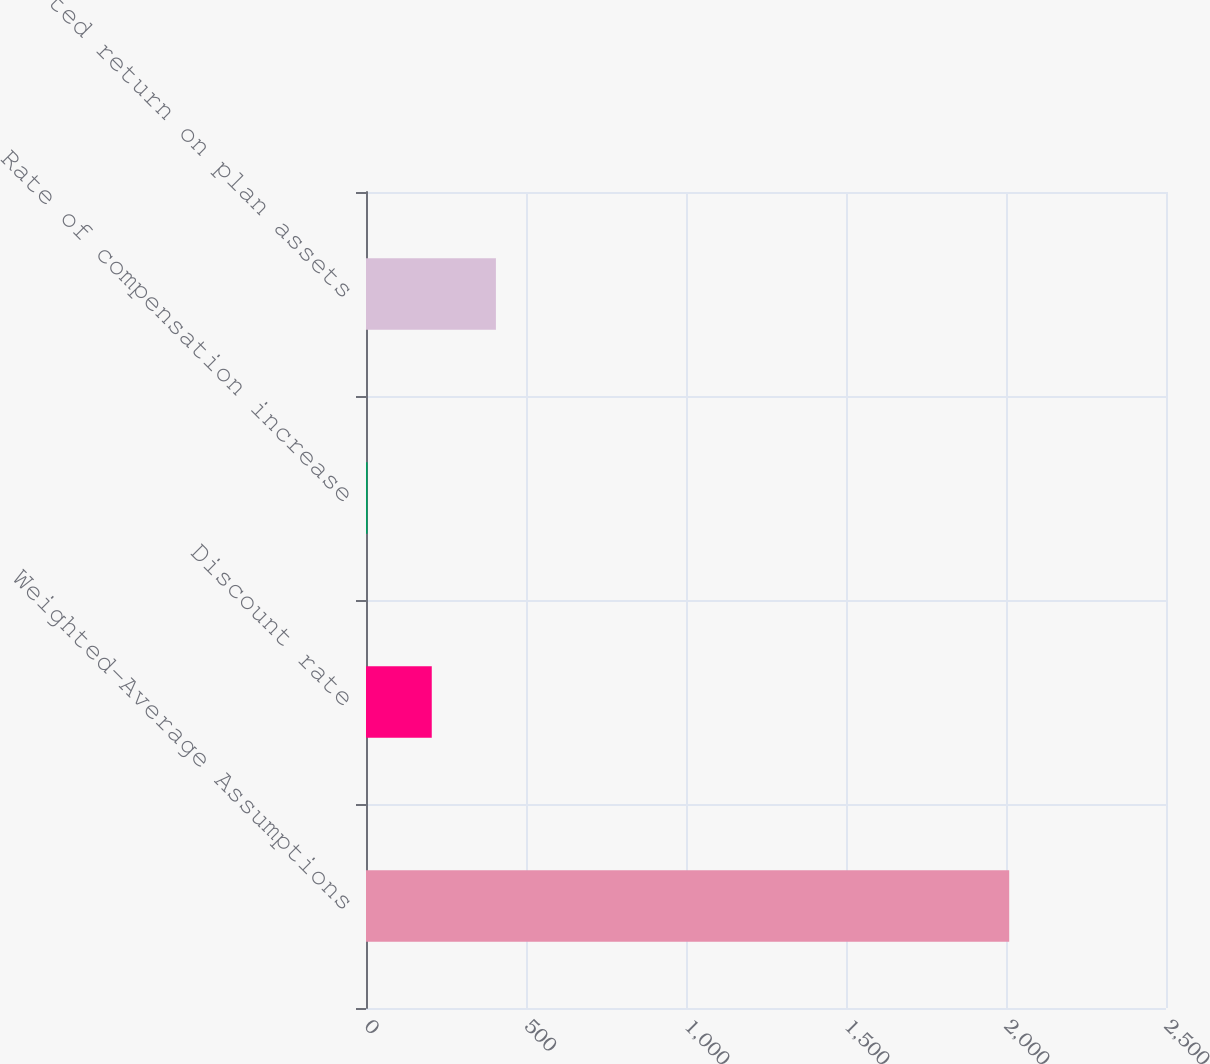Convert chart. <chart><loc_0><loc_0><loc_500><loc_500><bar_chart><fcel>Weighted-Average Assumptions<fcel>Discount rate<fcel>Rate of compensation increase<fcel>Expected return on plan assets<nl><fcel>2010<fcel>205.5<fcel>5<fcel>406<nl></chart> 